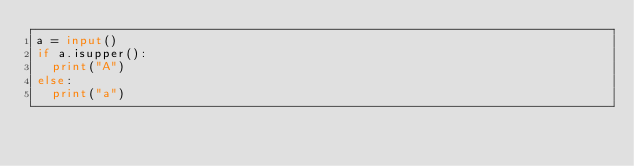Convert code to text. <code><loc_0><loc_0><loc_500><loc_500><_Python_>a = input()
if a.isupper():
  print("A")
else:
  print("a")</code> 